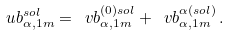<formula> <loc_0><loc_0><loc_500><loc_500>\ u b _ { \alpha , 1 m } ^ { s o l } = \ v b _ { \alpha , 1 m } ^ { ( 0 ) s o l } + \ v b _ { \alpha , 1 m } ^ { \alpha ( s o l ) } \, .</formula> 